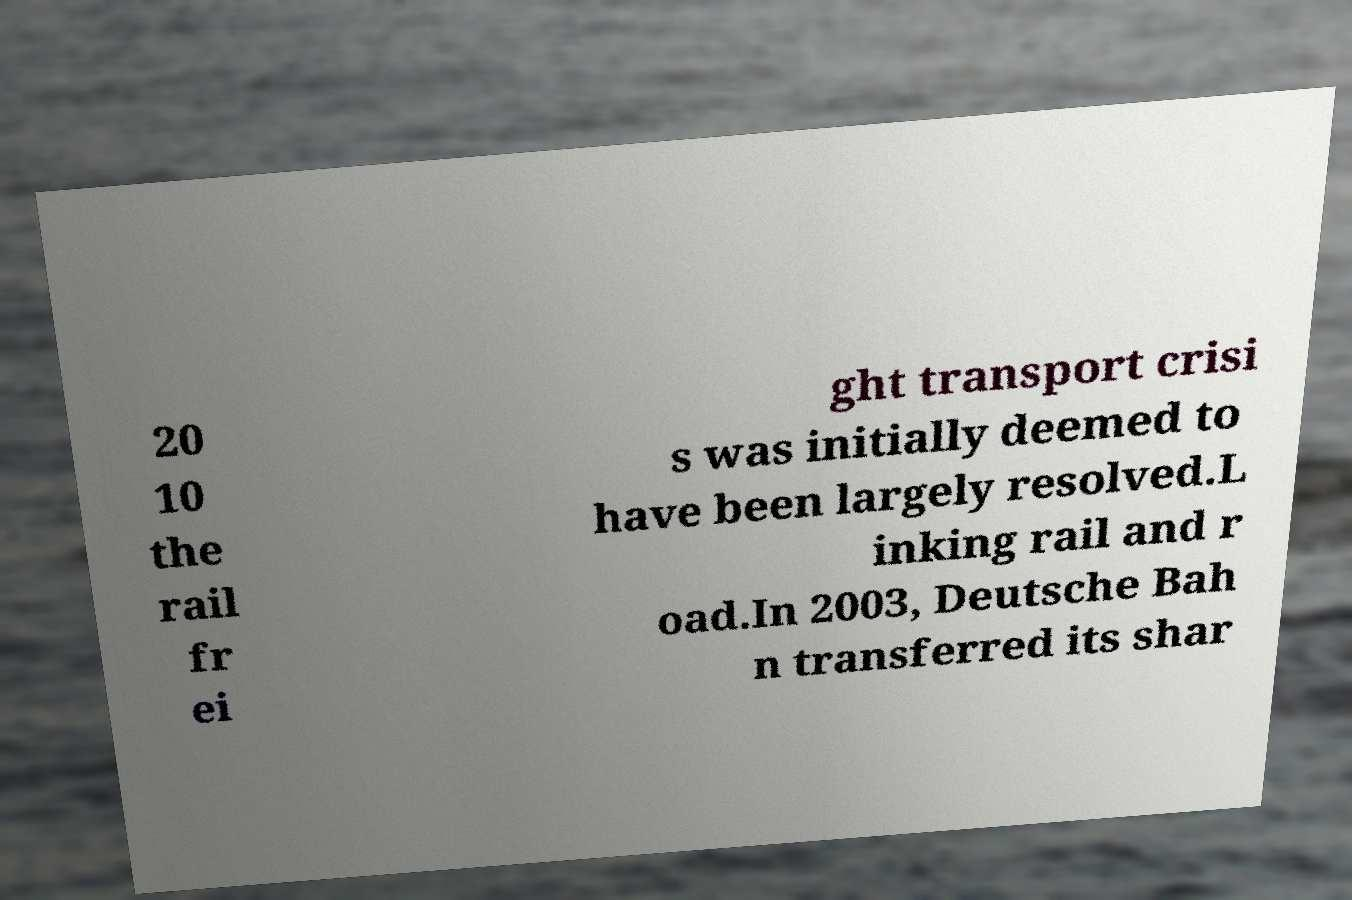Please identify and transcribe the text found in this image. 20 10 the rail fr ei ght transport crisi s was initially deemed to have been largely resolved.L inking rail and r oad.In 2003, Deutsche Bah n transferred its shar 